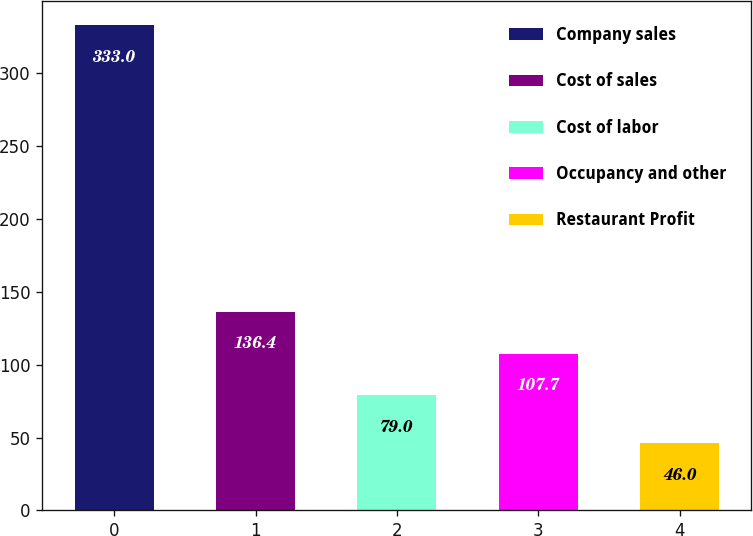Convert chart. <chart><loc_0><loc_0><loc_500><loc_500><bar_chart><fcel>Company sales<fcel>Cost of sales<fcel>Cost of labor<fcel>Occupancy and other<fcel>Restaurant Profit<nl><fcel>333<fcel>136.4<fcel>79<fcel>107.7<fcel>46<nl></chart> 